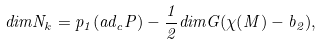<formula> <loc_0><loc_0><loc_500><loc_500>d i m N _ { k } = p _ { 1 } ( a d _ { c } P ) - \frac { 1 } { 2 } d i m G ( \chi ( M ) - b _ { 2 } ) ,</formula> 